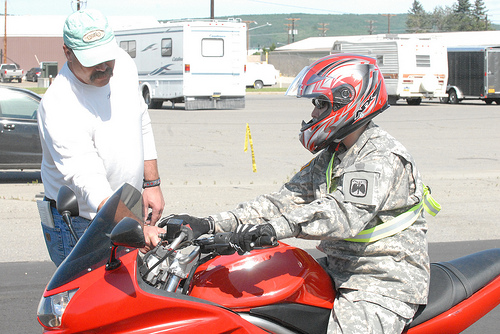<image>
Is there a man behind the motorcycle? No. The man is not behind the motorcycle. From this viewpoint, the man appears to be positioned elsewhere in the scene. 